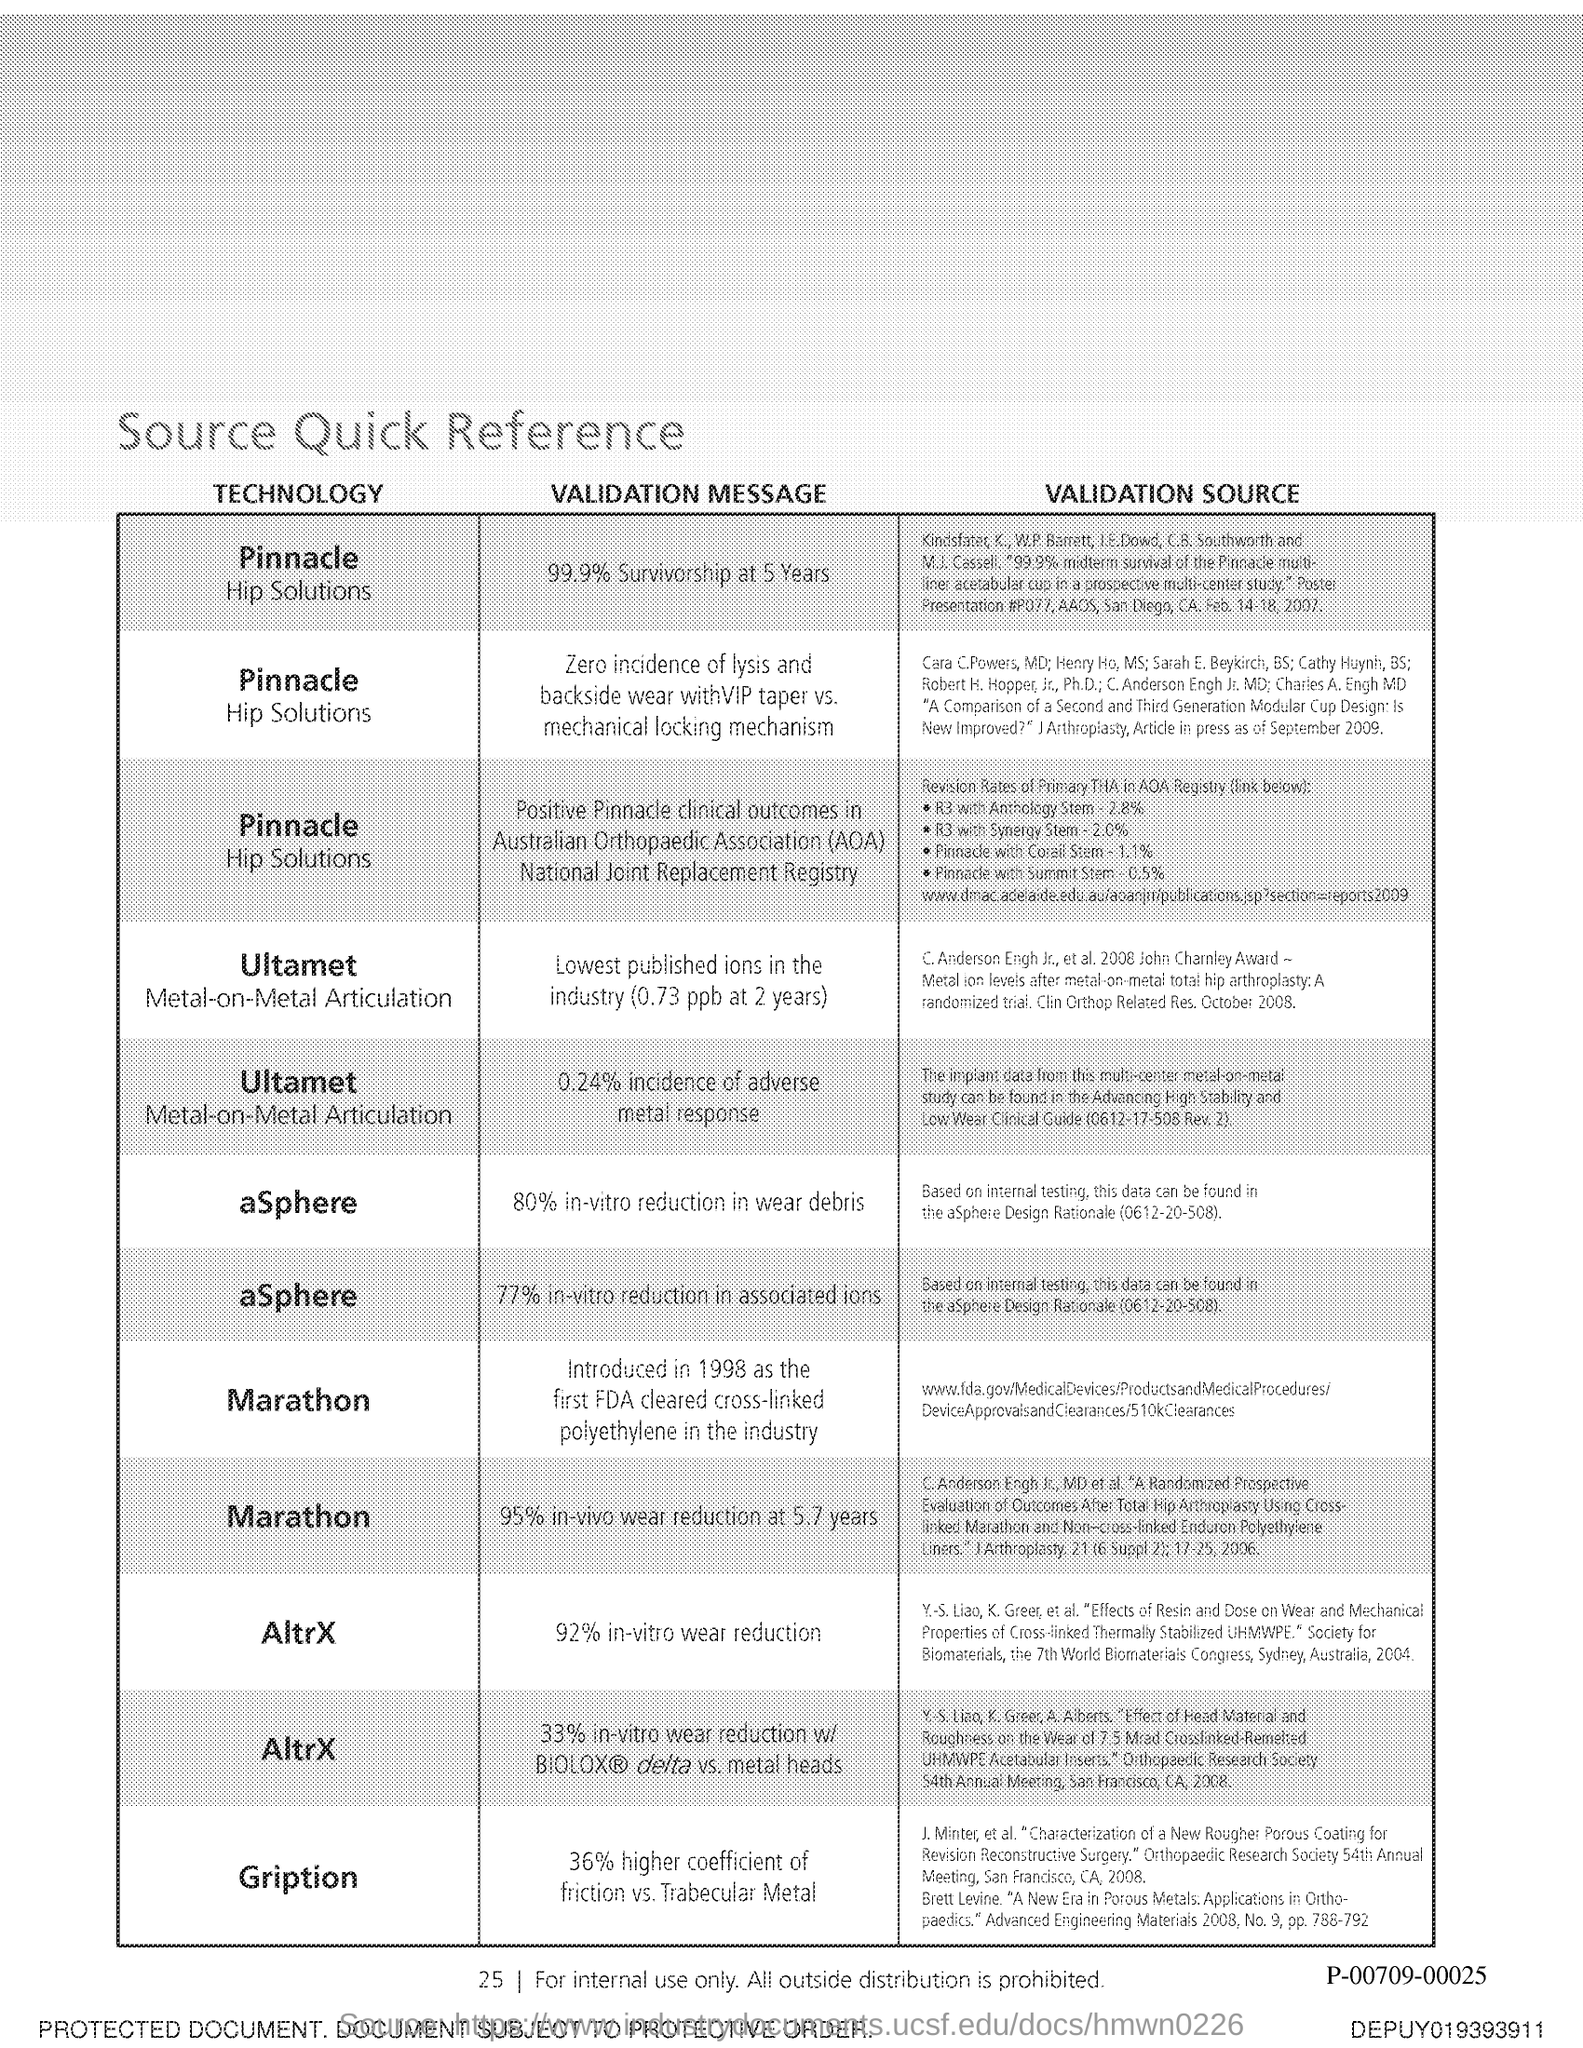Identify some key points in this picture. Gription's coefficient of friction is 36% higher compared to Trabecular Metal. 